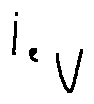Convert formula to latex. <formula><loc_0><loc_0><loc_500><loc_500>i _ { e _ { V } }</formula> 